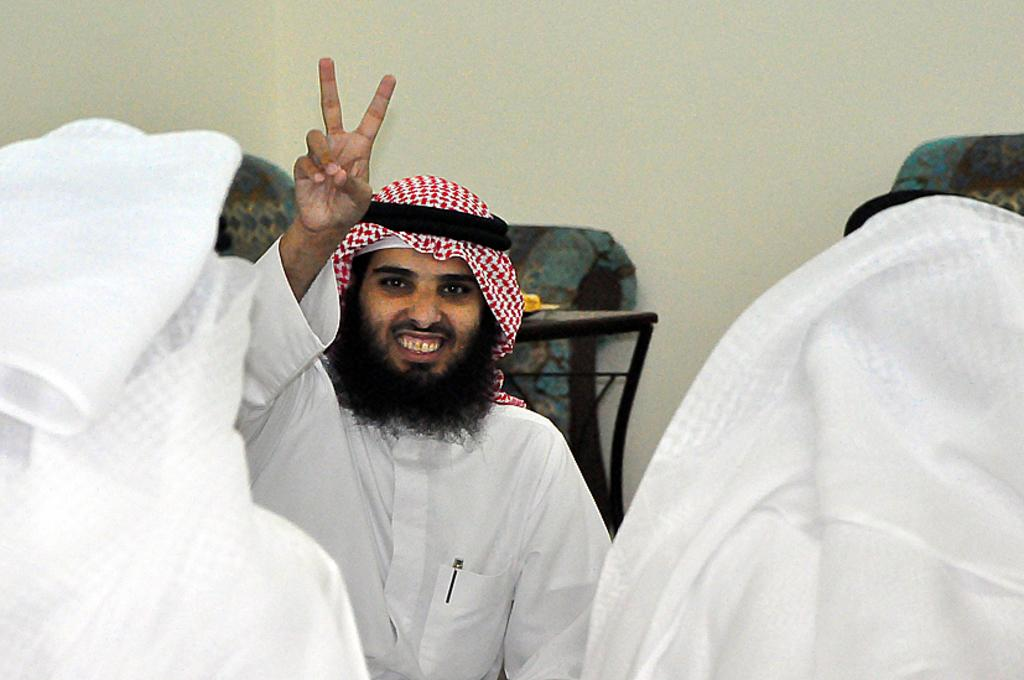How many people are in the image? There are people in the image, but the exact number is not specified. Can you describe the facial expression of one of the people? Yes, a man is smiling in the image. What can be seen in the background of the image? There is a table and a wall in the background of the image. What type of key is the man holding in the image? There is no key present in the image; only people, a smiling man, a table, and a wall are mentioned. 